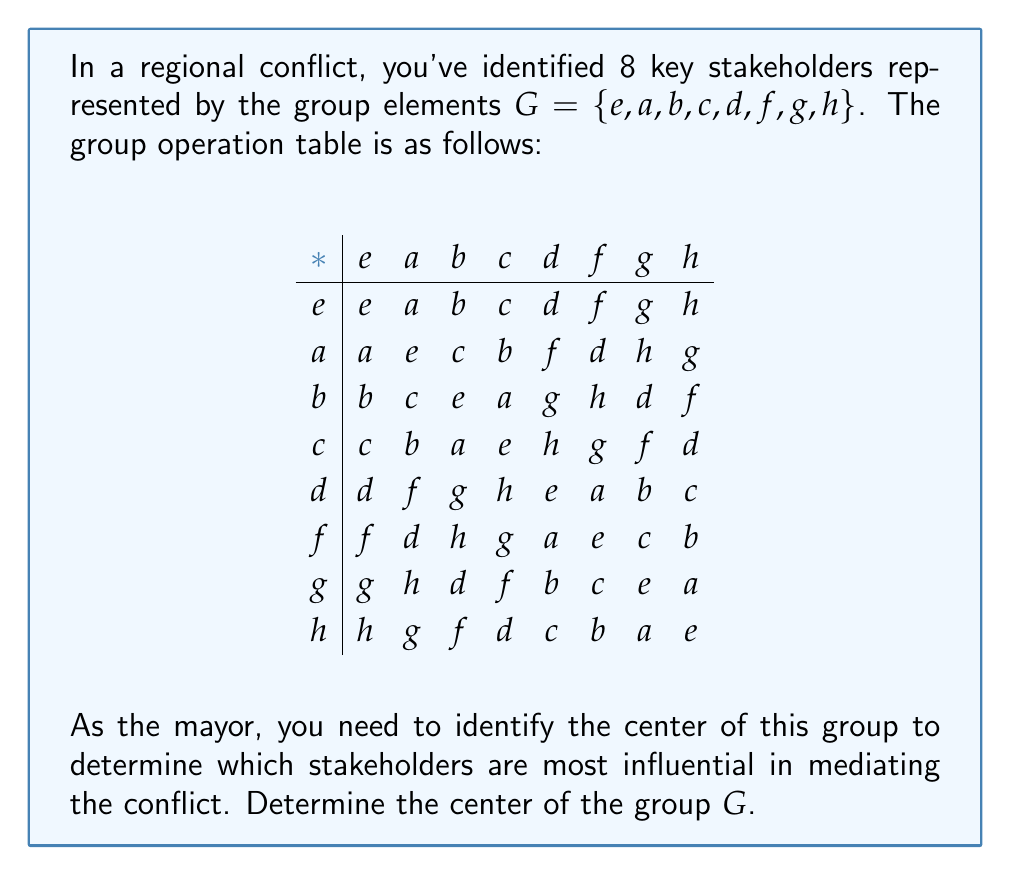Give your solution to this math problem. To solve this problem, we need to follow these steps:

1) Recall that the center of a group $G$ is defined as:
   
   $Z(G) = \{z \in G : zg = gz \text{ for all } g \in G\}$

   In other words, the center consists of all elements that commute with every element in the group.

2) We need to check each element of $G$ to see if it commutes with all other elements.

3) Let's start with $e$:
   $e$ commutes with all elements (it's the identity), so $e$ is in the center.

4) For $a$:
   $a * b = c$, but $b * a = c$
   $a * c = b$, but $c * a = b$
   $a * d = f$, but $d * a = f$
   So $a$ commutes with all elements and is in the center.

5) For $b$:
   $b * a = c$, but $a * b = c$
   $b * c = a$, but $c * b = a$
   $b * d = g$, but $d * b = g$
   So $b$ commutes with all elements and is in the center.

6) For $c$:
   $c * a = b$, but $a * c = b$
   $c * b = a$, but $b * c = a$
   $c * d = h$, but $d * c = h$
   So $c$ commutes with all elements and is in the center.

7) For $d$:
   $d * a = f$, but $a * d = f$
   $d * b = g$, but $b * d = g$
   $d * c = h$, but $c * d = h$
   So $d$ commutes with all elements and is in the center.

8) Similarly, we can check that $f$, $g$, and $h$ also commute with all elements.

9) Therefore, all elements of $G$ are in the center.

This means that $Z(G) = G$, and the group is abelian (commutative).
Answer: The center of the group $G$ is $Z(G) = \{e, a, b, c, d, f, g, h\} = G$. The group is abelian. 